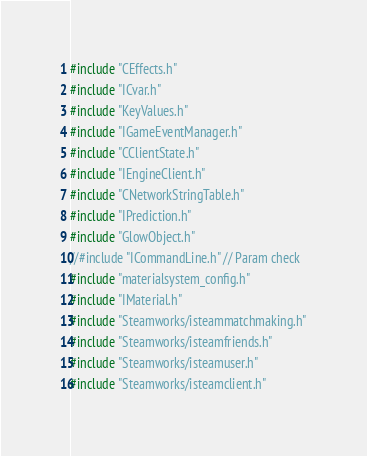Convert code to text. <code><loc_0><loc_0><loc_500><loc_500><_C_>#include "CEffects.h"
#include "ICvar.h"
#include "KeyValues.h"
#include "IGameEventManager.h"
#include "CClientState.h"
#include "IEngineClient.h"
#include "CNetworkStringTable.h"
#include "IPrediction.h"
#include "GlowObject.h"
//#include "ICommandLine.h" // Param check
#include "materialsystem_config.h"
#include "IMaterial.h"
#include "Steamworks/isteammatchmaking.h"
#include "Steamworks/isteamfriends.h"
#include "Steamworks/isteamuser.h"
#include "Steamworks/isteamclient.h"
</code> 